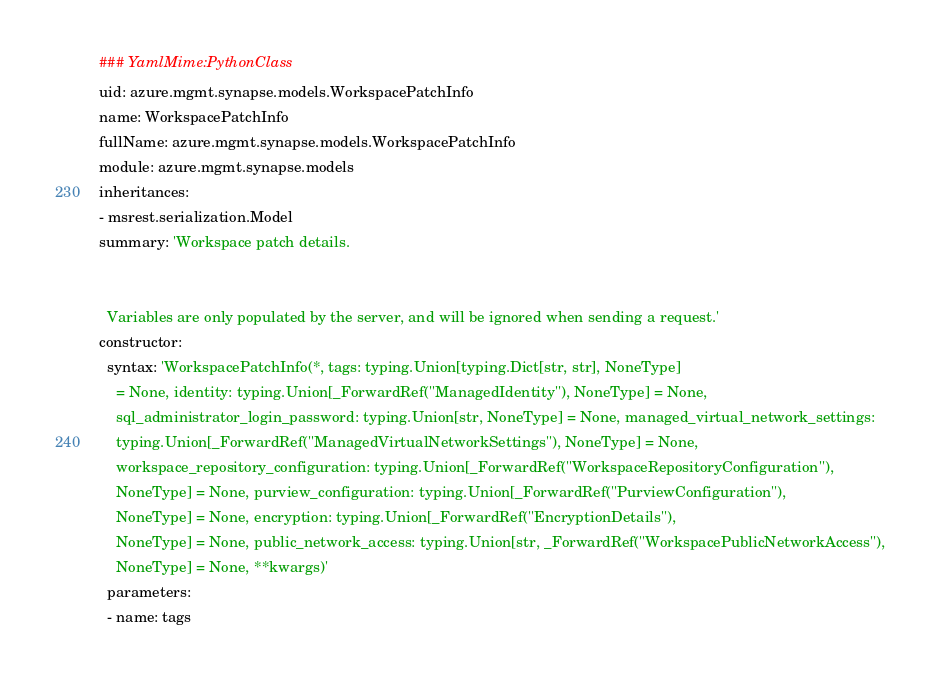<code> <loc_0><loc_0><loc_500><loc_500><_YAML_>### YamlMime:PythonClass
uid: azure.mgmt.synapse.models.WorkspacePatchInfo
name: WorkspacePatchInfo
fullName: azure.mgmt.synapse.models.WorkspacePatchInfo
module: azure.mgmt.synapse.models
inheritances:
- msrest.serialization.Model
summary: 'Workspace patch details.


  Variables are only populated by the server, and will be ignored when sending a request.'
constructor:
  syntax: 'WorkspacePatchInfo(*, tags: typing.Union[typing.Dict[str, str], NoneType]
    = None, identity: typing.Union[_ForwardRef(''ManagedIdentity''), NoneType] = None,
    sql_administrator_login_password: typing.Union[str, NoneType] = None, managed_virtual_network_settings:
    typing.Union[_ForwardRef(''ManagedVirtualNetworkSettings''), NoneType] = None,
    workspace_repository_configuration: typing.Union[_ForwardRef(''WorkspaceRepositoryConfiguration''),
    NoneType] = None, purview_configuration: typing.Union[_ForwardRef(''PurviewConfiguration''),
    NoneType] = None, encryption: typing.Union[_ForwardRef(''EncryptionDetails''),
    NoneType] = None, public_network_access: typing.Union[str, _ForwardRef(''WorkspacePublicNetworkAccess''),
    NoneType] = None, **kwargs)'
  parameters:
  - name: tags</code> 